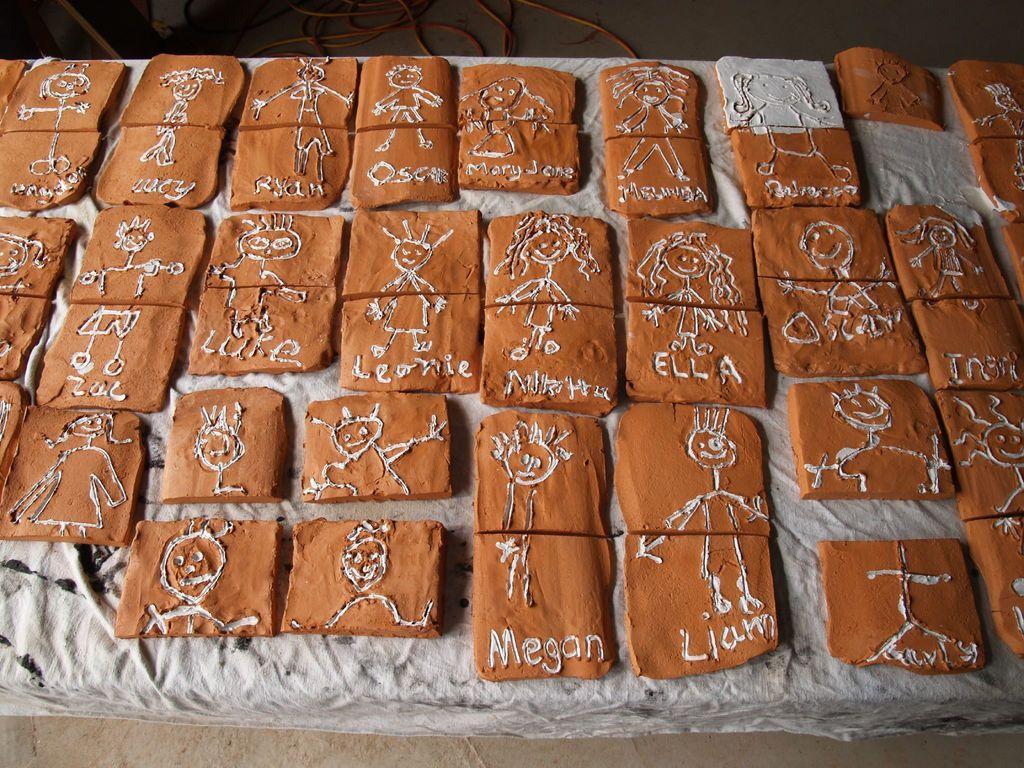Describe this image in one or two sentences. In the picture we can see some square shape objects which are made of clay and we can see some designs of persons and there are some names on it. 